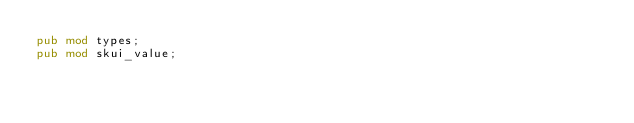<code> <loc_0><loc_0><loc_500><loc_500><_Rust_>pub mod types;
pub mod skui_value;
</code> 